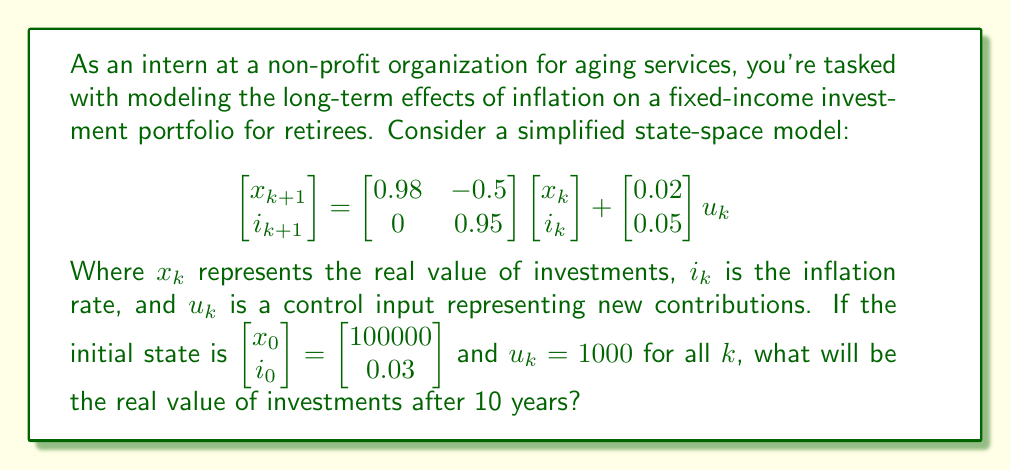Can you solve this math problem? Let's approach this step-by-step:

1) First, we need to iterate the state-space equation for 10 years (k = 0 to 9). We can do this using matrix multiplication.

2) Let's define our matrices:
   A = $\begin{bmatrix} 0.98 & -0.5 \\ 0 & 0.95 \end{bmatrix}$
   B = $\begin{bmatrix} 0.02 \\ 0.05 \end{bmatrix}$
   u = 1000 (constant)

3) The state update equation is:
   $\begin{bmatrix} x_{k+1} \\ i_{k+1} \end{bmatrix} = A\begin{bmatrix} x_k \\ i_k \end{bmatrix} + Bu_k$

4) We can iterate this 10 times:
   $\begin{bmatrix} x_{10} \\ i_{10} \end{bmatrix} = A^{10}\begin{bmatrix} x_0 \\ i_0 \end{bmatrix} + (A^9 + A^8 + ... + A + I)Bu$

5) Using a computer algebra system or programming language, we can calculate:
   $A^{10} \approx \begin{bmatrix} 0.8171 & -3.1623 \\ 0 & 0.5987 \end{bmatrix}$

   $(A^9 + A^8 + ... + A + I)B \approx \begin{bmatrix} 0.1829 \\ 0.4013 \end{bmatrix}$

6) Now we can plug in our initial values and calculate:
   $\begin{bmatrix} x_{10} \\ i_{10} \end{bmatrix} = \begin{bmatrix} 0.8171 & -3.1623 \\ 0 & 0.5987 \end{bmatrix}\begin{bmatrix} 100000 \\ 0.03 \end{bmatrix} + \begin{bmatrix} 0.1829 \\ 0.4013 \end{bmatrix}1000$

7) Solving this equation:
   $\begin{bmatrix} x_{10} \\ i_{10} \end{bmatrix} \approx \begin{bmatrix} 81615 \\ 0.0180 \end{bmatrix}$

8) The real value of investments after 10 years is approximately $81,615.
Answer: $81,615 